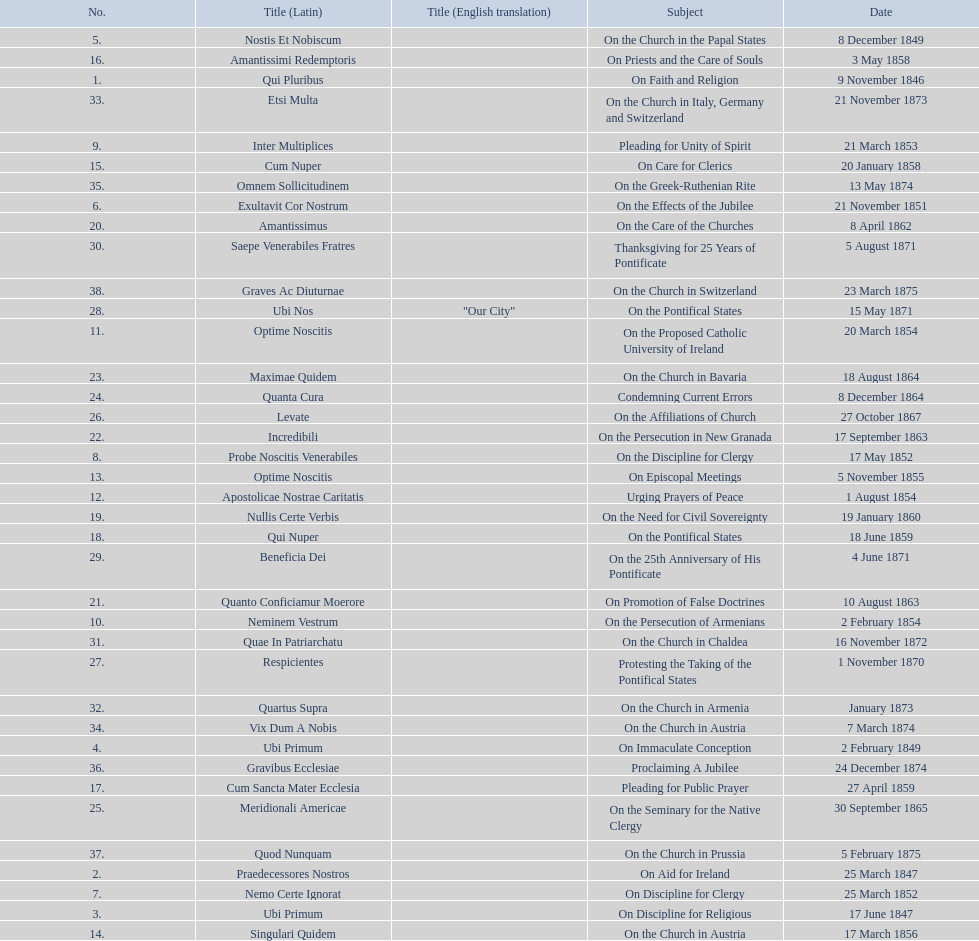How many subjects are there? 38. 